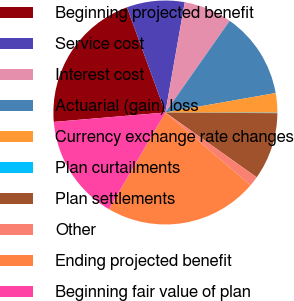<chart> <loc_0><loc_0><loc_500><loc_500><pie_chart><fcel>Beginning projected benefit<fcel>Service cost<fcel>Interest cost<fcel>Actuarial (gain) loss<fcel>Currency exchange rate changes<fcel>Plan curtailments<fcel>Plan settlements<fcel>Other<fcel>Ending projected benefit<fcel>Beginning fair value of plan<nl><fcel>20.76%<fcel>8.34%<fcel>6.96%<fcel>12.48%<fcel>2.82%<fcel>0.06%<fcel>9.72%<fcel>1.44%<fcel>22.14%<fcel>15.24%<nl></chart> 